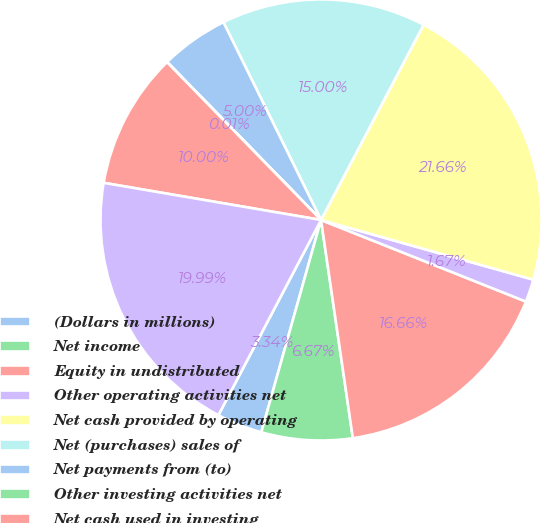Convert chart to OTSL. <chart><loc_0><loc_0><loc_500><loc_500><pie_chart><fcel>(Dollars in millions)<fcel>Net income<fcel>Equity in undistributed<fcel>Other operating activities net<fcel>Net cash provided by operating<fcel>Net (purchases) sales of<fcel>Net payments from (to)<fcel>Other investing activities net<fcel>Net cash used in investing<fcel>Net increase (decrease) in<nl><fcel>3.34%<fcel>6.67%<fcel>16.66%<fcel>1.67%<fcel>21.66%<fcel>15.0%<fcel>5.0%<fcel>0.01%<fcel>10.0%<fcel>19.99%<nl></chart> 